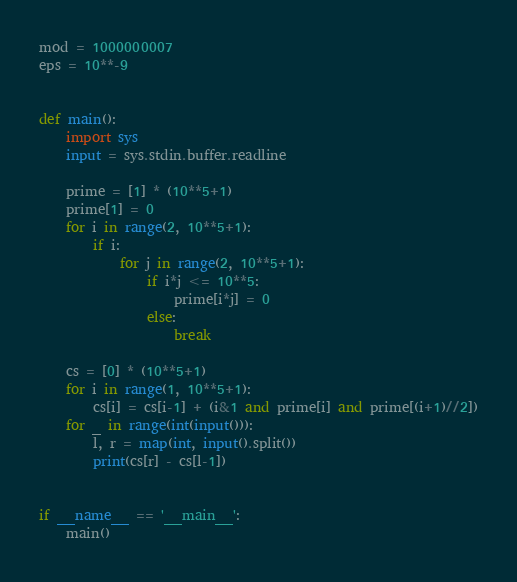<code> <loc_0><loc_0><loc_500><loc_500><_Python_>mod = 1000000007
eps = 10**-9


def main():
    import sys
    input = sys.stdin.buffer.readline

    prime = [1] * (10**5+1)
    prime[1] = 0
    for i in range(2, 10**5+1):
        if i:
            for j in range(2, 10**5+1):
                if i*j <= 10**5:
                    prime[i*j] = 0
                else:
                    break

    cs = [0] * (10**5+1)
    for i in range(1, 10**5+1):
        cs[i] = cs[i-1] + (i&1 and prime[i] and prime[(i+1)//2])
    for _ in range(int(input())):
        l, r = map(int, input().split())
        print(cs[r] - cs[l-1])


if __name__ == '__main__':
    main()
</code> 